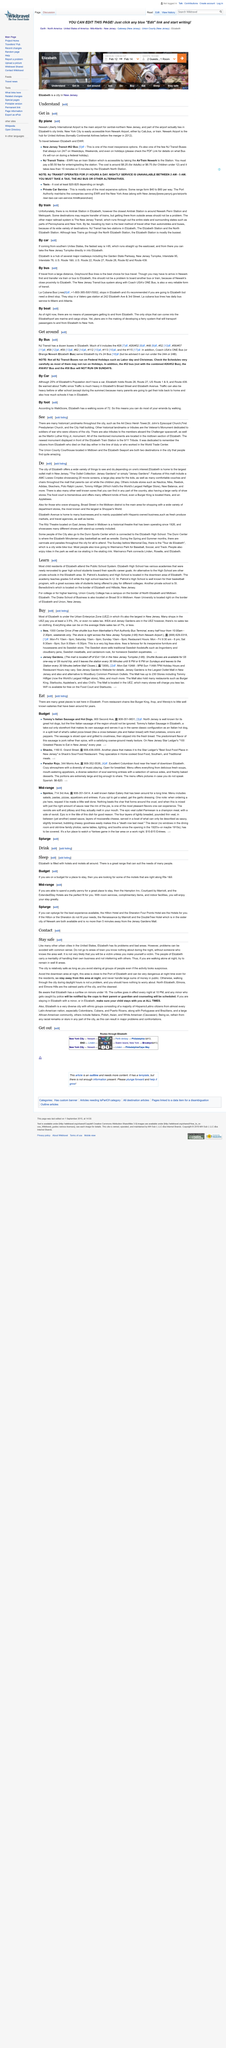Specify some key components in this picture. First Presbyterian Church in Elizabeth is a historical landmark. Both the Art Deco Hersh Tower and the Union County Courthouse are located in Elizabeth. Yes, there are many historical landmarks throughout the city of Elizabeth. 